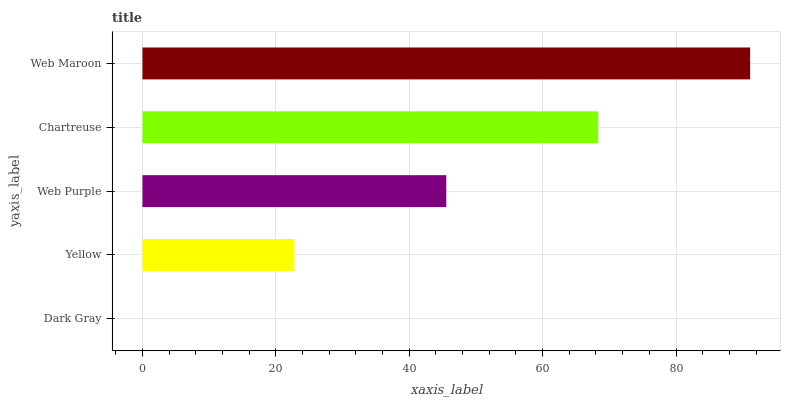Is Dark Gray the minimum?
Answer yes or no. Yes. Is Web Maroon the maximum?
Answer yes or no. Yes. Is Yellow the minimum?
Answer yes or no. No. Is Yellow the maximum?
Answer yes or no. No. Is Yellow greater than Dark Gray?
Answer yes or no. Yes. Is Dark Gray less than Yellow?
Answer yes or no. Yes. Is Dark Gray greater than Yellow?
Answer yes or no. No. Is Yellow less than Dark Gray?
Answer yes or no. No. Is Web Purple the high median?
Answer yes or no. Yes. Is Web Purple the low median?
Answer yes or no. Yes. Is Yellow the high median?
Answer yes or no. No. Is Web Maroon the low median?
Answer yes or no. No. 